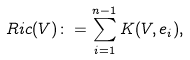Convert formula to latex. <formula><loc_0><loc_0><loc_500><loc_500>R i c ( V ) \colon = \sum _ { i = 1 } ^ { n - 1 } K ( V , e _ { i } ) ,</formula> 